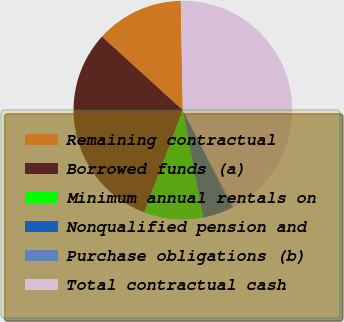Convert chart. <chart><loc_0><loc_0><loc_500><loc_500><pie_chart><fcel>Remaining contractual<fcel>Borrowed funds (a)<fcel>Minimum annual rentals on<fcel>Nonqualified pension and<fcel>Purchase obligations (b)<fcel>Total contractual cash<nl><fcel>12.95%<fcel>31.0%<fcel>8.71%<fcel>4.47%<fcel>0.23%<fcel>42.63%<nl></chart> 